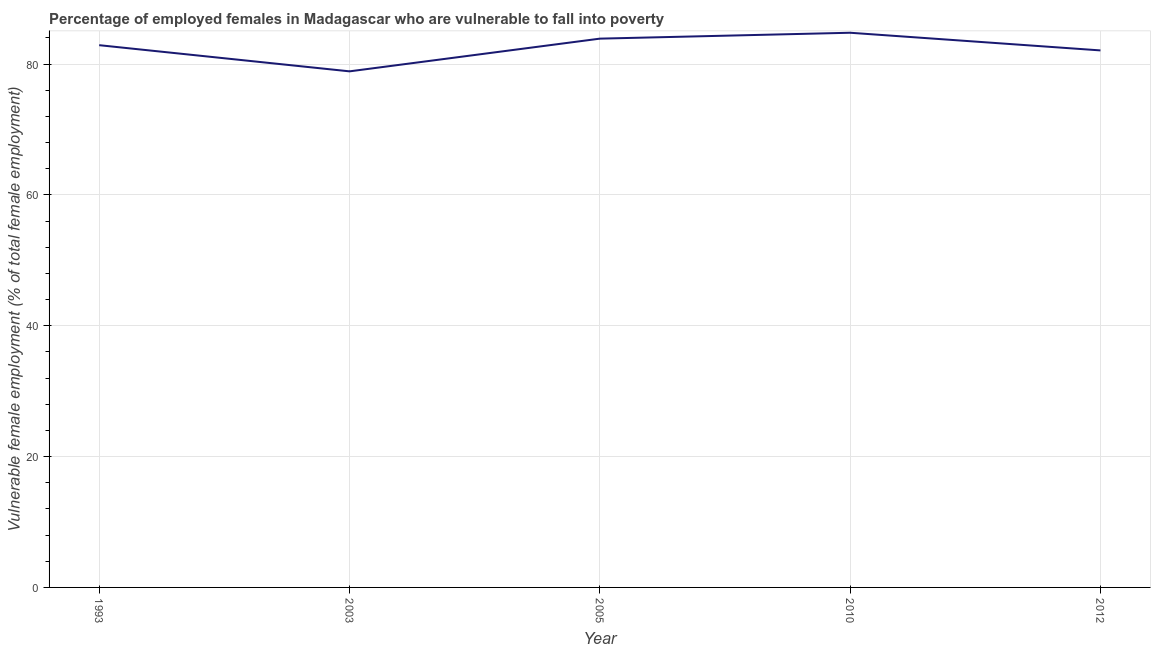What is the percentage of employed females who are vulnerable to fall into poverty in 1993?
Keep it short and to the point. 82.9. Across all years, what is the maximum percentage of employed females who are vulnerable to fall into poverty?
Your response must be concise. 84.8. Across all years, what is the minimum percentage of employed females who are vulnerable to fall into poverty?
Your answer should be compact. 78.9. In which year was the percentage of employed females who are vulnerable to fall into poverty maximum?
Keep it short and to the point. 2010. What is the sum of the percentage of employed females who are vulnerable to fall into poverty?
Provide a succinct answer. 412.6. What is the difference between the percentage of employed females who are vulnerable to fall into poverty in 2005 and 2012?
Your response must be concise. 1.8. What is the average percentage of employed females who are vulnerable to fall into poverty per year?
Your answer should be very brief. 82.52. What is the median percentage of employed females who are vulnerable to fall into poverty?
Provide a short and direct response. 82.9. Do a majority of the years between 2010 and 2003 (inclusive) have percentage of employed females who are vulnerable to fall into poverty greater than 60 %?
Offer a very short reply. No. What is the ratio of the percentage of employed females who are vulnerable to fall into poverty in 2003 to that in 2012?
Keep it short and to the point. 0.96. Is the difference between the percentage of employed females who are vulnerable to fall into poverty in 2003 and 2012 greater than the difference between any two years?
Your answer should be very brief. No. What is the difference between the highest and the second highest percentage of employed females who are vulnerable to fall into poverty?
Offer a terse response. 0.9. Is the sum of the percentage of employed females who are vulnerable to fall into poverty in 1993 and 2003 greater than the maximum percentage of employed females who are vulnerable to fall into poverty across all years?
Give a very brief answer. Yes. What is the difference between the highest and the lowest percentage of employed females who are vulnerable to fall into poverty?
Offer a very short reply. 5.9. Does the percentage of employed females who are vulnerable to fall into poverty monotonically increase over the years?
Keep it short and to the point. No. How many lines are there?
Make the answer very short. 1. Does the graph contain grids?
Your answer should be very brief. Yes. What is the title of the graph?
Keep it short and to the point. Percentage of employed females in Madagascar who are vulnerable to fall into poverty. What is the label or title of the X-axis?
Keep it short and to the point. Year. What is the label or title of the Y-axis?
Make the answer very short. Vulnerable female employment (% of total female employment). What is the Vulnerable female employment (% of total female employment) of 1993?
Offer a terse response. 82.9. What is the Vulnerable female employment (% of total female employment) in 2003?
Provide a short and direct response. 78.9. What is the Vulnerable female employment (% of total female employment) in 2005?
Give a very brief answer. 83.9. What is the Vulnerable female employment (% of total female employment) in 2010?
Offer a terse response. 84.8. What is the Vulnerable female employment (% of total female employment) of 2012?
Offer a very short reply. 82.1. What is the difference between the Vulnerable female employment (% of total female employment) in 1993 and 2010?
Offer a very short reply. -1.9. What is the difference between the Vulnerable female employment (% of total female employment) in 2010 and 2012?
Keep it short and to the point. 2.7. What is the ratio of the Vulnerable female employment (% of total female employment) in 1993 to that in 2003?
Provide a succinct answer. 1.05. What is the ratio of the Vulnerable female employment (% of total female employment) in 1993 to that in 2010?
Provide a succinct answer. 0.98. What is the ratio of the Vulnerable female employment (% of total female employment) in 1993 to that in 2012?
Offer a very short reply. 1.01. What is the ratio of the Vulnerable female employment (% of total female employment) in 2005 to that in 2012?
Your answer should be compact. 1.02. What is the ratio of the Vulnerable female employment (% of total female employment) in 2010 to that in 2012?
Keep it short and to the point. 1.03. 